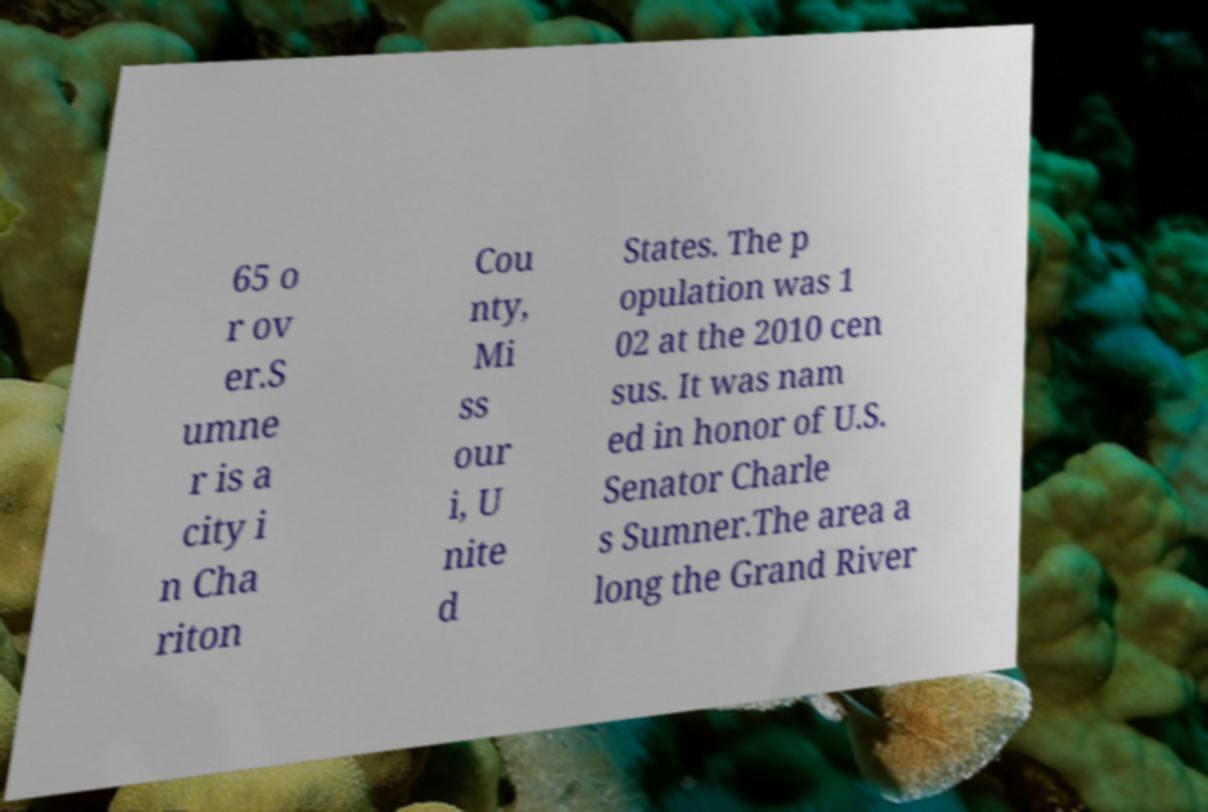Can you read and provide the text displayed in the image?This photo seems to have some interesting text. Can you extract and type it out for me? 65 o r ov er.S umne r is a city i n Cha riton Cou nty, Mi ss our i, U nite d States. The p opulation was 1 02 at the 2010 cen sus. It was nam ed in honor of U.S. Senator Charle s Sumner.The area a long the Grand River 